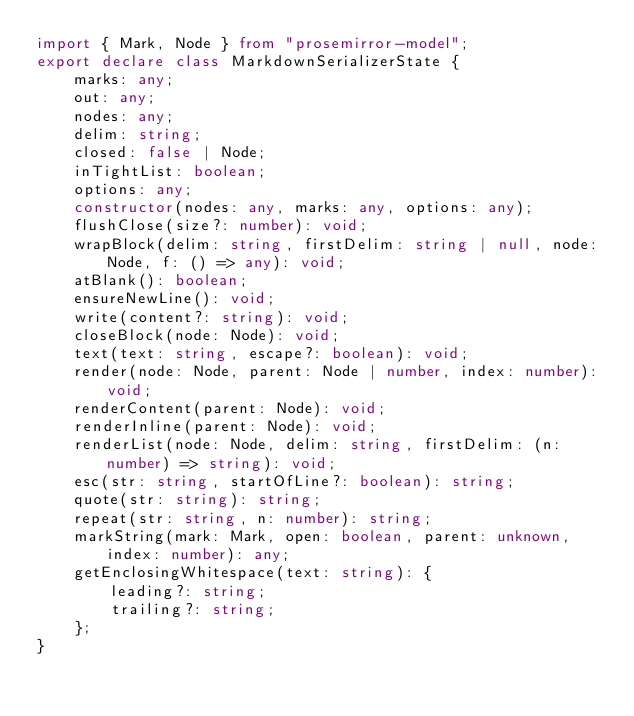<code> <loc_0><loc_0><loc_500><loc_500><_TypeScript_>import { Mark, Node } from "prosemirror-model";
export declare class MarkdownSerializerState {
    marks: any;
    out: any;
    nodes: any;
    delim: string;
    closed: false | Node;
    inTightList: boolean;
    options: any;
    constructor(nodes: any, marks: any, options: any);
    flushClose(size?: number): void;
    wrapBlock(delim: string, firstDelim: string | null, node: Node, f: () => any): void;
    atBlank(): boolean;
    ensureNewLine(): void;
    write(content?: string): void;
    closeBlock(node: Node): void;
    text(text: string, escape?: boolean): void;
    render(node: Node, parent: Node | number, index: number): void;
    renderContent(parent: Node): void;
    renderInline(parent: Node): void;
    renderList(node: Node, delim: string, firstDelim: (n: number) => string): void;
    esc(str: string, startOfLine?: boolean): string;
    quote(str: string): string;
    repeat(str: string, n: number): string;
    markString(mark: Mark, open: boolean, parent: unknown, index: number): any;
    getEnclosingWhitespace(text: string): {
        leading?: string;
        trailing?: string;
    };
}
</code> 